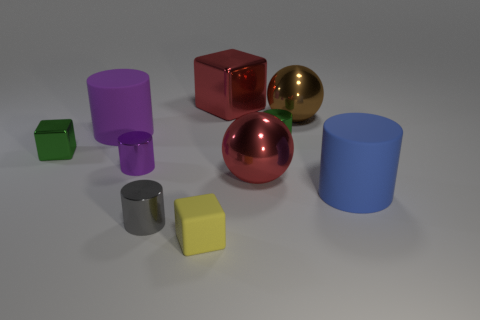There is a big red object that is in front of the brown ball; what shape is it?
Ensure brevity in your answer.  Sphere. What number of tiny gray rubber cylinders are there?
Your response must be concise. 0. Do the tiny green cylinder and the large blue cylinder have the same material?
Make the answer very short. No. Are there more tiny cubes that are left of the small gray thing than gray metal objects?
Keep it short and to the point. No. What number of objects are either small green objects or large objects left of the tiny yellow cube?
Ensure brevity in your answer.  3. Is the number of small yellow matte things behind the tiny purple object greater than the number of big cubes that are in front of the small green cube?
Your response must be concise. No. The tiny block in front of the large matte cylinder that is in front of the small block behind the blue thing is made of what material?
Provide a succinct answer. Rubber. The tiny purple object that is made of the same material as the green cylinder is what shape?
Offer a terse response. Cylinder. Is there a purple shiny object that is behind the big object that is on the left side of the purple shiny thing?
Make the answer very short. No. The gray metal cylinder has what size?
Offer a terse response. Small. 